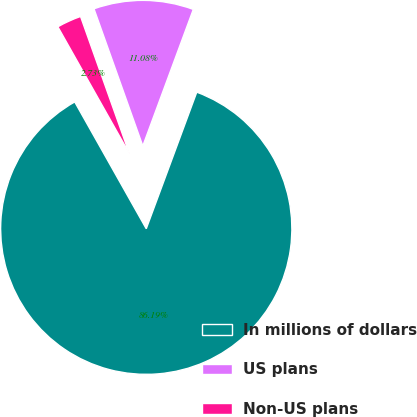<chart> <loc_0><loc_0><loc_500><loc_500><pie_chart><fcel>In millions of dollars<fcel>US plans<fcel>Non-US plans<nl><fcel>86.19%<fcel>11.08%<fcel>2.73%<nl></chart> 